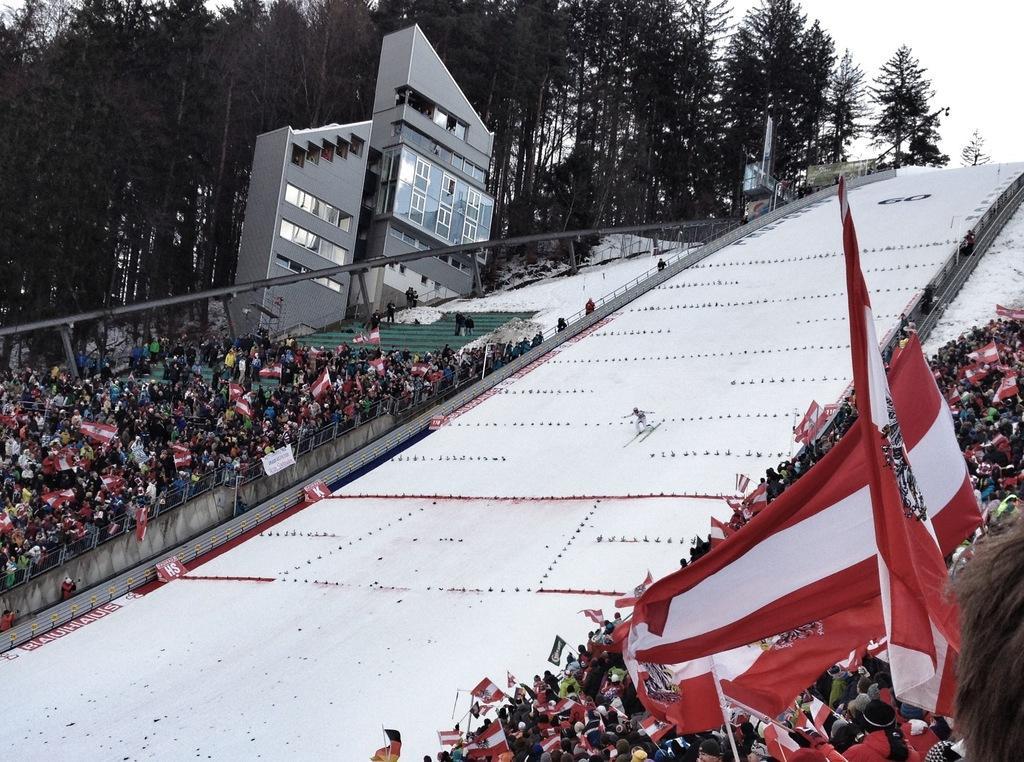In one or two sentences, can you explain what this image depicts? In this picture we can see crowd, flags, trees, building, and a banner. Here we can see a person skiing on the snow. In the background there is sky. 